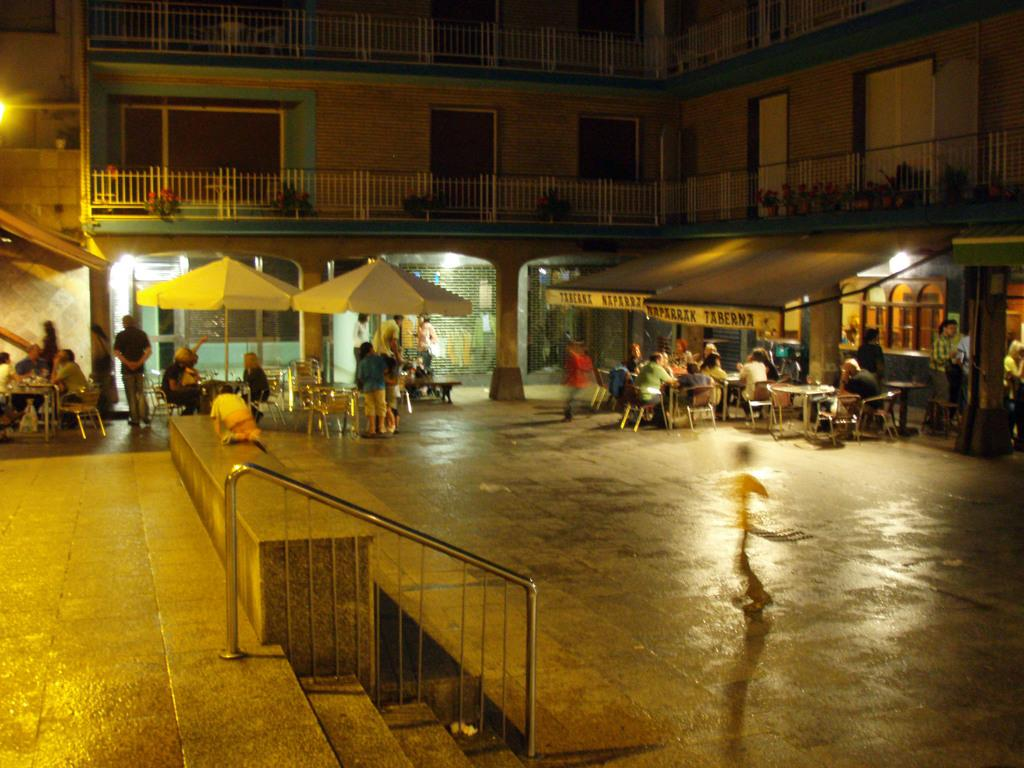How many people are in the image? There are persons in the image, but the exact number cannot be determined from the provided facts. What type of furniture is present in the image? There are tables and chairs in the image. What type of shelter is visible in the image? There is a building in the image. What architectural features can be seen in the image? There are stairs, fencing, a wall, a door, and windows in the image. What type of protection from the elements is present in the image? There are umbrellas in the image. What song is being sung by the persons in the image? There is no information about any singing or songs in the image. How much dust is visible on the tables in the image? There is no information about the presence of dust on the tables in the image. 